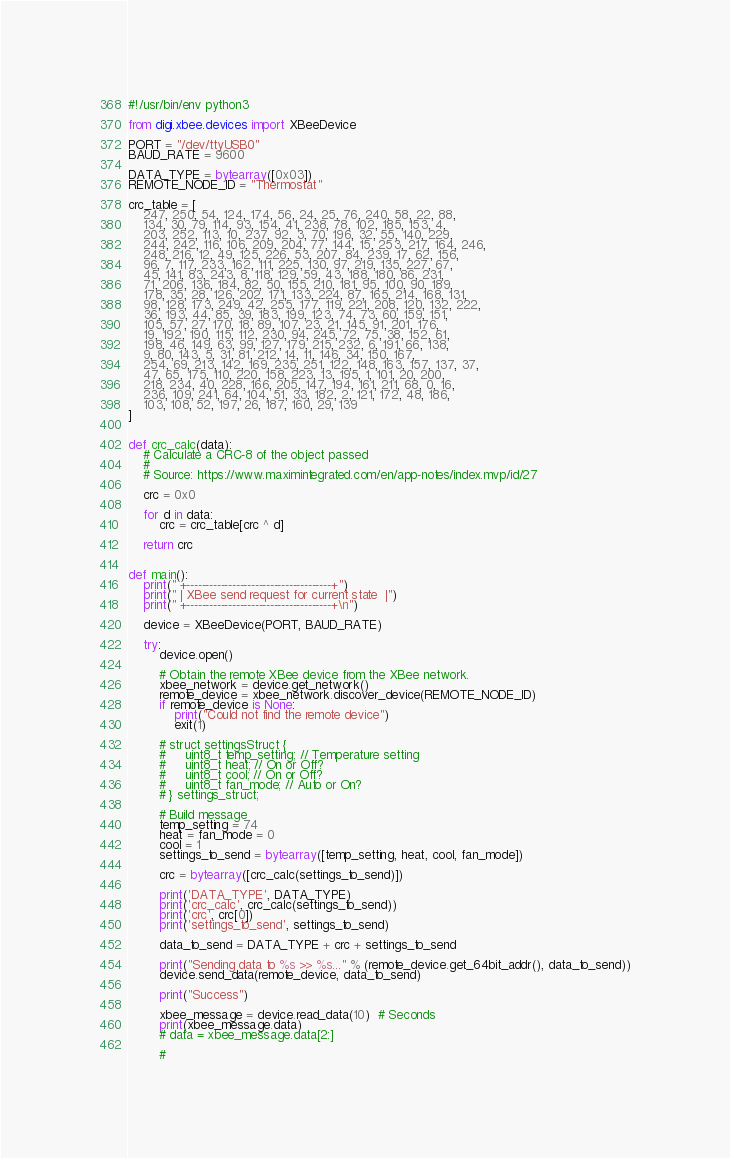<code> <loc_0><loc_0><loc_500><loc_500><_Python_>#!/usr/bin/env python3

from digi.xbee.devices import XBeeDevice

PORT = "/dev/ttyUSB0"
BAUD_RATE = 9600

DATA_TYPE = bytearray([0x03])
REMOTE_NODE_ID = "Thermostat"

crc_table = [
    247, 250, 54, 124, 174, 56, 24, 25, 76, 240, 58, 22, 88,
    134, 30, 79, 114, 93, 154, 41, 238, 78, 102, 185, 153, 4,
    203, 252, 113, 10, 237, 92, 3, 70, 196, 32, 55, 140, 229,
    244, 242, 116, 106, 209, 204, 77, 144, 15, 253, 217, 164, 246,
    248, 216, 12, 49, 125, 226, 53, 207, 84, 239, 17, 62, 156,
    96, 7, 117, 233, 162, 111, 225, 130, 97, 219, 135, 227, 67,
    45, 141, 83, 243, 8, 118, 129, 59, 43, 188, 180, 86, 231,
    71, 206, 136, 184, 82, 50, 155, 210, 181, 95, 100, 90, 189,
    178, 35, 28, 126, 202, 171, 133, 224, 87, 165, 214, 168, 131,
    98, 128, 173, 249, 42, 255, 177, 119, 221, 208, 120, 132, 222,
    36, 193, 44, 85, 39, 183, 199, 123, 74, 73, 60, 159, 151,
    105, 57, 27, 170, 18, 89, 107, 23, 21, 145, 91, 201, 176,
    19, 192, 190, 115, 112, 230, 94, 245, 72, 75, 38, 152, 61,
    198, 46, 149, 63, 99, 127, 179, 215, 232, 6, 191, 66, 138,
    9, 80, 143, 5, 31, 81, 212, 14, 11, 146, 34, 150, 167,
    254, 69, 213, 142, 169, 235, 251, 122, 148, 163, 157, 137, 37,
    47, 65, 175, 110, 220, 158, 223, 13, 195, 1, 101, 20, 200,
    218, 234, 40, 228, 166, 205, 147, 194, 161, 211, 68, 0, 16,
    236, 109, 241, 64, 104, 51, 33, 182, 2, 121, 172, 48, 186,
    103, 108, 52, 197, 26, 187, 160, 29, 139
]


def crc_calc(data):
    # Calculate a CRC-8 of the object passed
    #
    # Source: https://www.maximintegrated.com/en/app-notes/index.mvp/id/27

    crc = 0x0

    for d in data:
        crc = crc_table[crc ^ d]

    return crc


def main():
    print(" +--------------------------------------+")
    print(" | XBee send request for current state  |")
    print(" +--------------------------------------+\n")

    device = XBeeDevice(PORT, BAUD_RATE)

    try:
        device.open()

        # Obtain the remote XBee device from the XBee network.
        xbee_network = device.get_network()
        remote_device = xbee_network.discover_device(REMOTE_NODE_ID)
        if remote_device is None:
            print("Could not find the remote device")
            exit(1)

        # struct settingsStruct {
        #     uint8_t temp_setting; // Temperature setting
        #     uint8_t heat; // On or Off?
        #     uint8_t cool; // On or Off?
        #     uint8_t fan_mode; // Auto or On?
        # } settings_struct;

        # Build message
        temp_setting = 74
        heat = fan_mode = 0
        cool = 1
        settings_to_send = bytearray([temp_setting, heat, cool, fan_mode])

        crc = bytearray([crc_calc(settings_to_send)])

        print('DATA_TYPE', DATA_TYPE)
        print('crc_calc', crc_calc(settings_to_send))
        print('crc', crc[0])
        print('settings_to_send', settings_to_send)

        data_to_send = DATA_TYPE + crc + settings_to_send

        print("Sending data to %s >> %s..." % (remote_device.get_64bit_addr(), data_to_send))
        device.send_data(remote_device, data_to_send)

        print("Success")

        xbee_message = device.read_data(10)  # Seconds
        print(xbee_message.data)
        # data = xbee_message.data[2:]

        #</code> 